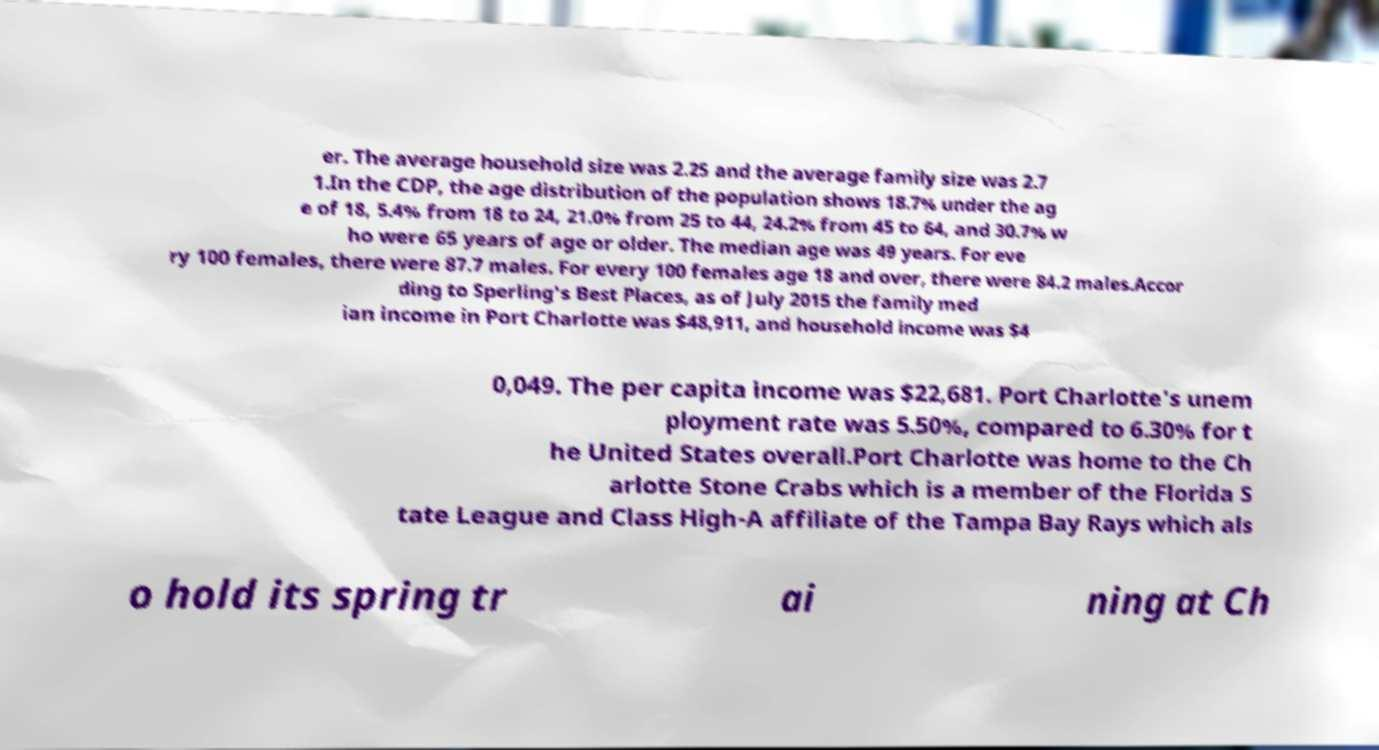What messages or text are displayed in this image? I need them in a readable, typed format. er. The average household size was 2.25 and the average family size was 2.7 1.In the CDP, the age distribution of the population shows 18.7% under the ag e of 18, 5.4% from 18 to 24, 21.0% from 25 to 44, 24.2% from 45 to 64, and 30.7% w ho were 65 years of age or older. The median age was 49 years. For eve ry 100 females, there were 87.7 males. For every 100 females age 18 and over, there were 84.2 males.Accor ding to Sperling's Best Places, as of July 2015 the family med ian income in Port Charlotte was $48,911, and household income was $4 0,049. The per capita income was $22,681. Port Charlotte's unem ployment rate was 5.50%, compared to 6.30% for t he United States overall.Port Charlotte was home to the Ch arlotte Stone Crabs which is a member of the Florida S tate League and Class High-A affiliate of the Tampa Bay Rays which als o hold its spring tr ai ning at Ch 